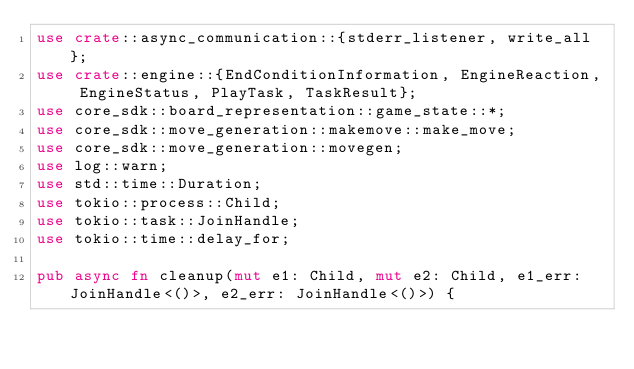<code> <loc_0><loc_0><loc_500><loc_500><_Rust_>use crate::async_communication::{stderr_listener, write_all};
use crate::engine::{EndConditionInformation, EngineReaction, EngineStatus, PlayTask, TaskResult};
use core_sdk::board_representation::game_state::*;
use core_sdk::move_generation::makemove::make_move;
use core_sdk::move_generation::movegen;
use log::warn;
use std::time::Duration;
use tokio::process::Child;
use tokio::task::JoinHandle;
use tokio::time::delay_for;

pub async fn cleanup(mut e1: Child, mut e2: Child, e1_err: JoinHandle<()>, e2_err: JoinHandle<()>) {</code> 